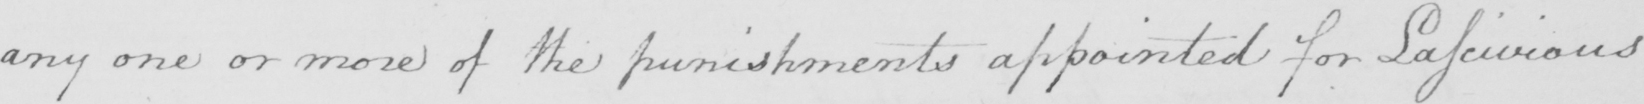What text is written in this handwritten line? any one or more of the punishments appointed for Lascivious 